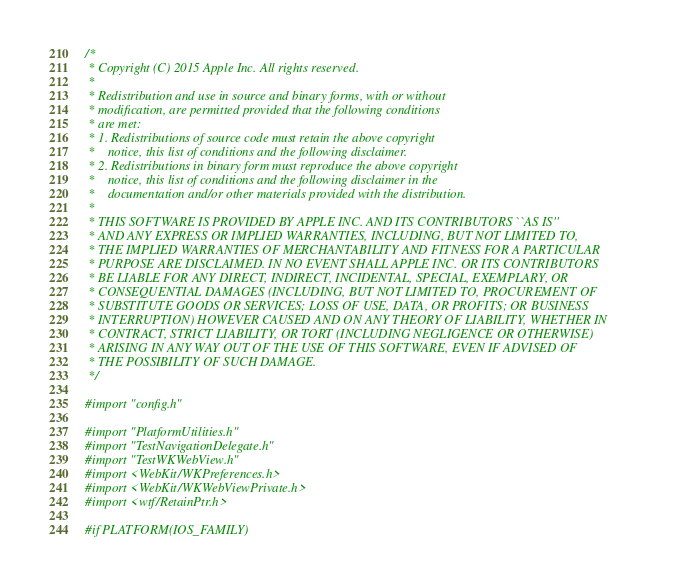Convert code to text. <code><loc_0><loc_0><loc_500><loc_500><_ObjectiveC_>/*
 * Copyright (C) 2015 Apple Inc. All rights reserved.
 *
 * Redistribution and use in source and binary forms, with or without
 * modification, are permitted provided that the following conditions
 * are met:
 * 1. Redistributions of source code must retain the above copyright
 *    notice, this list of conditions and the following disclaimer.
 * 2. Redistributions in binary form must reproduce the above copyright
 *    notice, this list of conditions and the following disclaimer in the
 *    documentation and/or other materials provided with the distribution.
 *
 * THIS SOFTWARE IS PROVIDED BY APPLE INC. AND ITS CONTRIBUTORS ``AS IS''
 * AND ANY EXPRESS OR IMPLIED WARRANTIES, INCLUDING, BUT NOT LIMITED TO,
 * THE IMPLIED WARRANTIES OF MERCHANTABILITY AND FITNESS FOR A PARTICULAR
 * PURPOSE ARE DISCLAIMED. IN NO EVENT SHALL APPLE INC. OR ITS CONTRIBUTORS
 * BE LIABLE FOR ANY DIRECT, INDIRECT, INCIDENTAL, SPECIAL, EXEMPLARY, OR
 * CONSEQUENTIAL DAMAGES (INCLUDING, BUT NOT LIMITED TO, PROCUREMENT OF
 * SUBSTITUTE GOODS OR SERVICES; LOSS OF USE, DATA, OR PROFITS; OR BUSINESS
 * INTERRUPTION) HOWEVER CAUSED AND ON ANY THEORY OF LIABILITY, WHETHER IN
 * CONTRACT, STRICT LIABILITY, OR TORT (INCLUDING NEGLIGENCE OR OTHERWISE)
 * ARISING IN ANY WAY OUT OF THE USE OF THIS SOFTWARE, EVEN IF ADVISED OF
 * THE POSSIBILITY OF SUCH DAMAGE.
 */

#import "config.h"

#import "PlatformUtilities.h"
#import "TestNavigationDelegate.h"
#import "TestWKWebView.h"
#import <WebKit/WKPreferences.h>
#import <WebKit/WKWebViewPrivate.h>
#import <wtf/RetainPtr.h>

#if PLATFORM(IOS_FAMILY)
</code> 